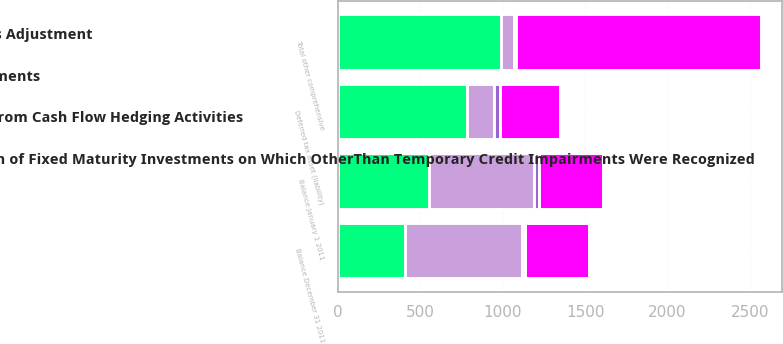<chart> <loc_0><loc_0><loc_500><loc_500><stacked_bar_chart><ecel><fcel>Balance January 1 2011<fcel>Deferred tax asset (liability)<fcel>Total other comprehensive<fcel>Balance December 31 2011<nl><fcel>Foreign Currency Translation Adjustments<fcel>634<fcel>163<fcel>74<fcel>711<nl><fcel>Unrealized Appreciation Depreciation of Fixed Maturity Investments on Which OtherThan Temporary Credit Impairments Were Recognized<fcel>385.5<fcel>362<fcel>1485<fcel>385.5<nl><fcel>Change in Retirement Plan Liabilities Adjustment<fcel>553<fcel>786<fcel>992<fcel>409<nl><fcel>Net Derivative Gains Losses Arising from Cash Flow Hedging Activities<fcel>34<fcel>34<fcel>17<fcel>17<nl></chart> 